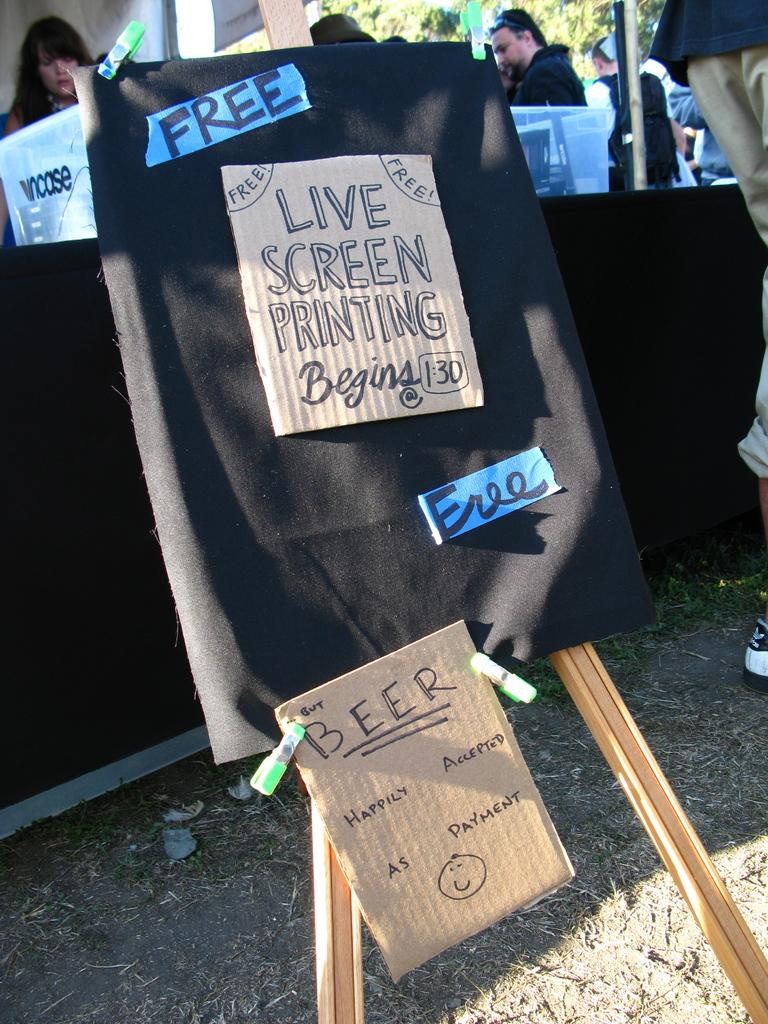What is the main object in the image? There is a stand in the image. What is covering the stand? A black cloth is present on the stand. What items are on the stand? There are boards, stickers, and clips on the stand. What can be seen in the background of the image? The background of the image includes people, hoardings, and a tree. Is there a kettle on the stand in the image? No, there is no kettle present on the stand in the image. What type of toothbrush is being used by the person in the background? There is no toothbrush visible in the image, as it focuses on the stand and its contents. 